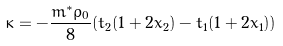<formula> <loc_0><loc_0><loc_500><loc_500>\kappa = - \frac { m ^ { * } \rho _ { 0 } } { 8 } ( t _ { 2 } ( 1 + 2 x _ { 2 } ) - t _ { 1 } ( 1 + 2 x _ { 1 } ) )</formula> 